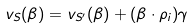<formula> <loc_0><loc_0><loc_500><loc_500>v _ { S } ( \beta ) = v _ { S ^ { \prime } } ( \beta ) + ( \beta \cdot \rho _ { i } ) \gamma</formula> 